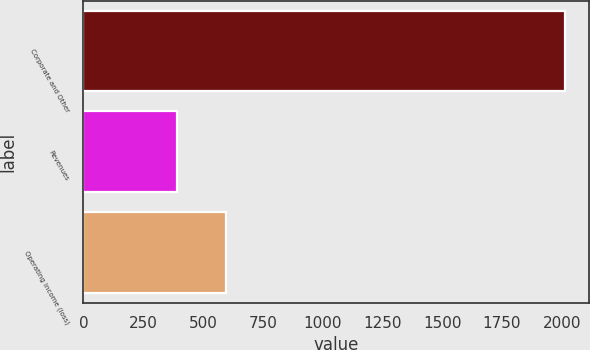Convert chart. <chart><loc_0><loc_0><loc_500><loc_500><bar_chart><fcel>Corporate and Other<fcel>Revenues<fcel>Operating income (loss)<nl><fcel>2012<fcel>390<fcel>597<nl></chart> 